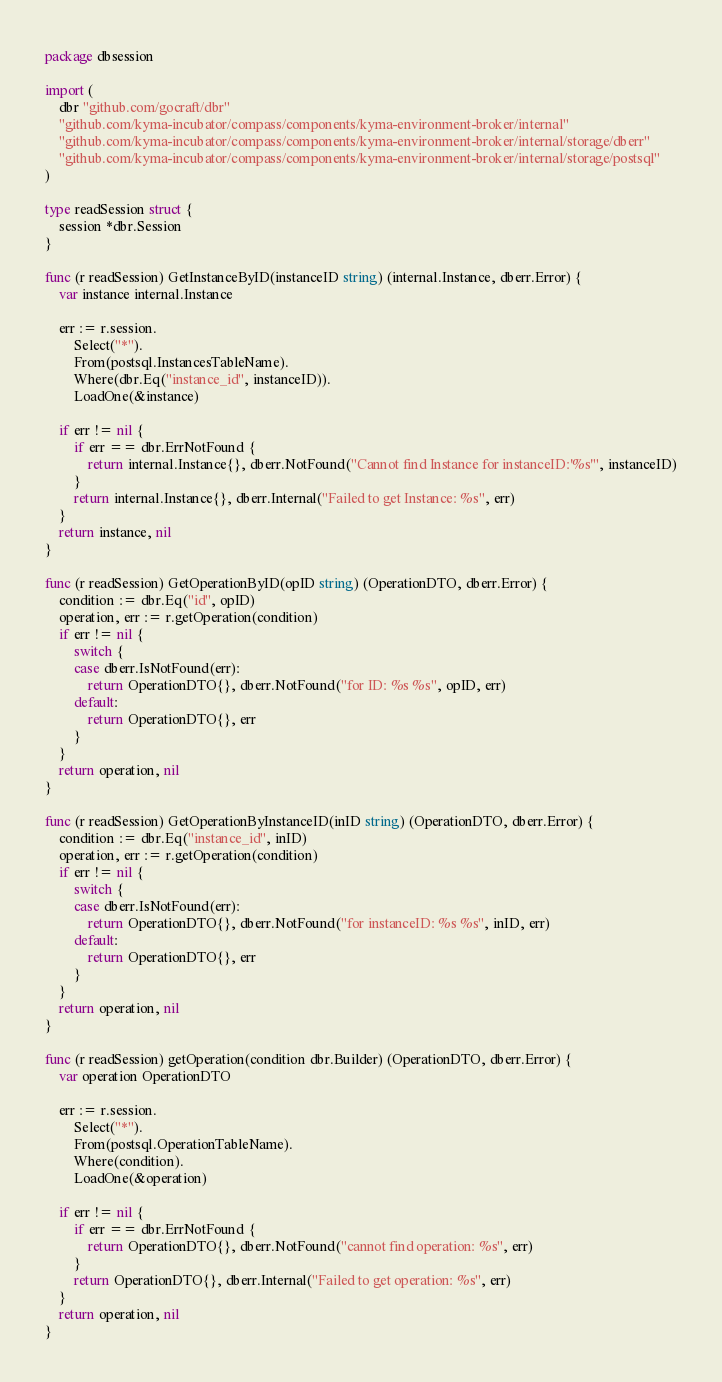Convert code to text. <code><loc_0><loc_0><loc_500><loc_500><_Go_>package dbsession

import (
	dbr "github.com/gocraft/dbr"
	"github.com/kyma-incubator/compass/components/kyma-environment-broker/internal"
	"github.com/kyma-incubator/compass/components/kyma-environment-broker/internal/storage/dberr"
	"github.com/kyma-incubator/compass/components/kyma-environment-broker/internal/storage/postsql"
)

type readSession struct {
	session *dbr.Session
}

func (r readSession) GetInstanceByID(instanceID string) (internal.Instance, dberr.Error) {
	var instance internal.Instance

	err := r.session.
		Select("*").
		From(postsql.InstancesTableName).
		Where(dbr.Eq("instance_id", instanceID)).
		LoadOne(&instance)

	if err != nil {
		if err == dbr.ErrNotFound {
			return internal.Instance{}, dberr.NotFound("Cannot find Instance for instanceID:'%s'", instanceID)
		}
		return internal.Instance{}, dberr.Internal("Failed to get Instance: %s", err)
	}
	return instance, nil
}

func (r readSession) GetOperationByID(opID string) (OperationDTO, dberr.Error) {
	condition := dbr.Eq("id", opID)
	operation, err := r.getOperation(condition)
	if err != nil {
		switch {
		case dberr.IsNotFound(err):
			return OperationDTO{}, dberr.NotFound("for ID: %s %s", opID, err)
		default:
			return OperationDTO{}, err
		}
	}
	return operation, nil
}

func (r readSession) GetOperationByInstanceID(inID string) (OperationDTO, dberr.Error) {
	condition := dbr.Eq("instance_id", inID)
	operation, err := r.getOperation(condition)
	if err != nil {
		switch {
		case dberr.IsNotFound(err):
			return OperationDTO{}, dberr.NotFound("for instanceID: %s %s", inID, err)
		default:
			return OperationDTO{}, err
		}
	}
	return operation, nil
}

func (r readSession) getOperation(condition dbr.Builder) (OperationDTO, dberr.Error) {
	var operation OperationDTO

	err := r.session.
		Select("*").
		From(postsql.OperationTableName).
		Where(condition).
		LoadOne(&operation)

	if err != nil {
		if err == dbr.ErrNotFound {
			return OperationDTO{}, dberr.NotFound("cannot find operation: %s", err)
		}
		return OperationDTO{}, dberr.Internal("Failed to get operation: %s", err)
	}
	return operation, nil
}
</code> 